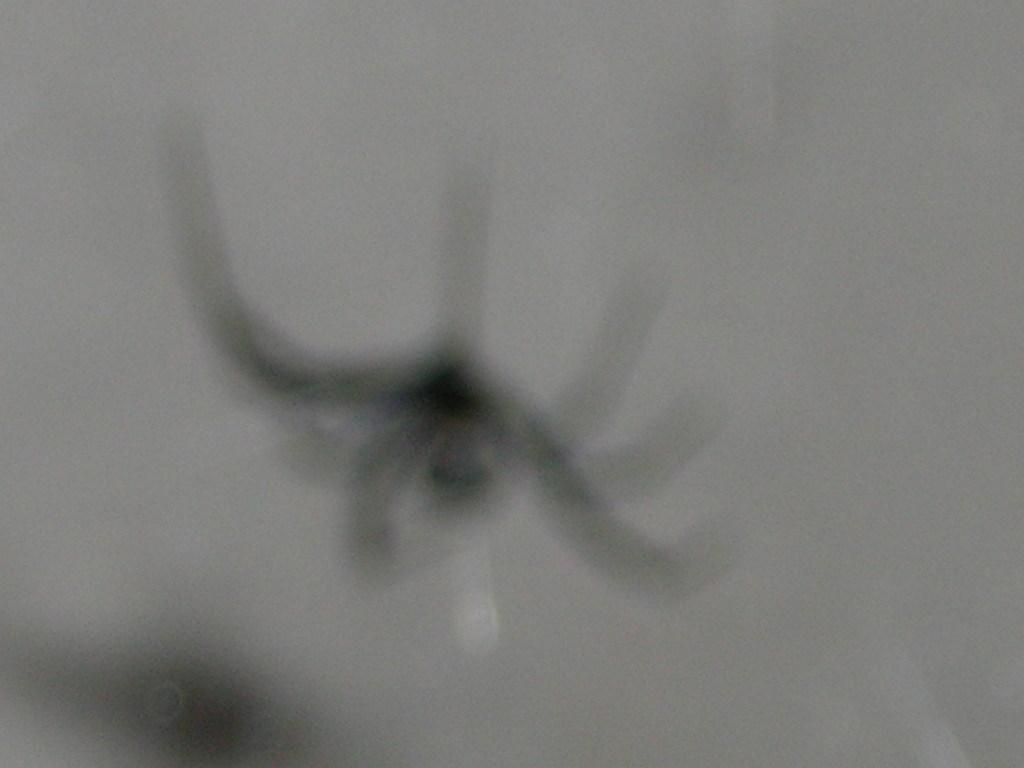How would you summarize this image in a sentence or two? In this image I can see a spider in black color and I can see white color background. 